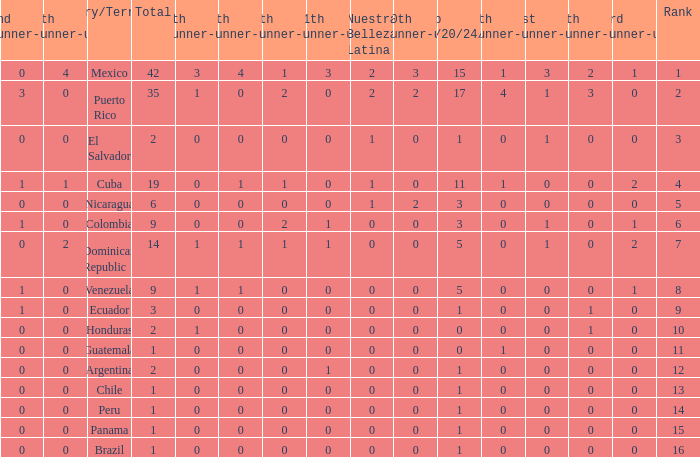What is the 3rd runner-up of the country with more than 0 9th runner-up, an 11th runner-up of 0, and the 1st runner-up greater than 0? None. 